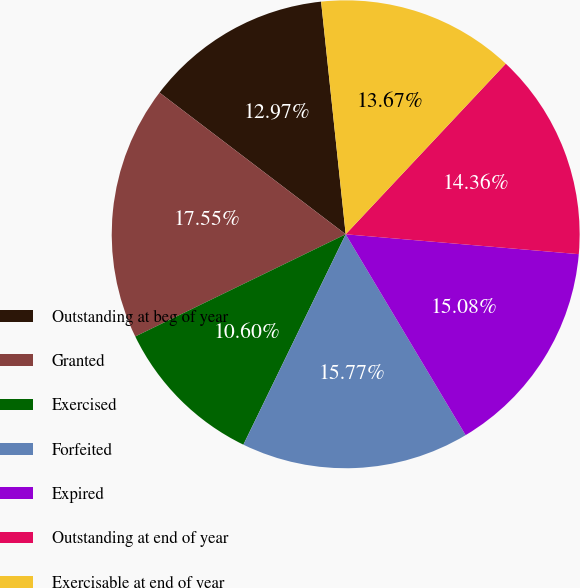<chart> <loc_0><loc_0><loc_500><loc_500><pie_chart><fcel>Outstanding at beg of year<fcel>Granted<fcel>Exercised<fcel>Forfeited<fcel>Expired<fcel>Outstanding at end of year<fcel>Exercisable at end of year<nl><fcel>12.97%<fcel>17.55%<fcel>10.6%<fcel>15.77%<fcel>15.08%<fcel>14.36%<fcel>13.67%<nl></chart> 